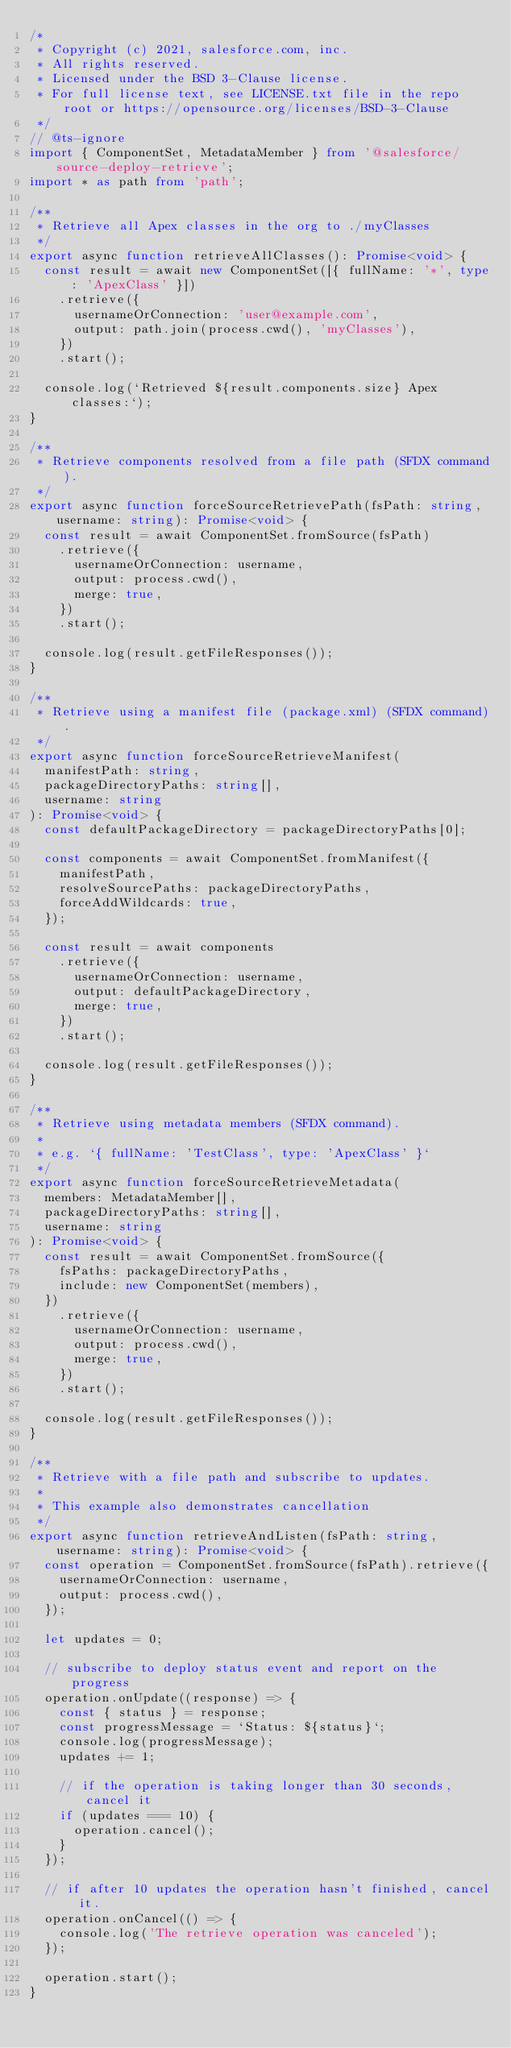<code> <loc_0><loc_0><loc_500><loc_500><_TypeScript_>/*
 * Copyright (c) 2021, salesforce.com, inc.
 * All rights reserved.
 * Licensed under the BSD 3-Clause license.
 * For full license text, see LICENSE.txt file in the repo root or https://opensource.org/licenses/BSD-3-Clause
 */
// @ts-ignore
import { ComponentSet, MetadataMember } from '@salesforce/source-deploy-retrieve';
import * as path from 'path';

/**
 * Retrieve all Apex classes in the org to ./myClasses
 */
export async function retrieveAllClasses(): Promise<void> {
  const result = await new ComponentSet([{ fullName: '*', type: 'ApexClass' }])
    .retrieve({
      usernameOrConnection: 'user@example.com',
      output: path.join(process.cwd(), 'myClasses'),
    })
    .start();

  console.log(`Retrieved ${result.components.size} Apex classes:`);
}

/**
 * Retrieve components resolved from a file path (SFDX command).
 */
export async function forceSourceRetrievePath(fsPath: string, username: string): Promise<void> {
  const result = await ComponentSet.fromSource(fsPath)
    .retrieve({
      usernameOrConnection: username,
      output: process.cwd(),
      merge: true,
    })
    .start();

  console.log(result.getFileResponses());
}

/**
 * Retrieve using a manifest file (package.xml) (SFDX command).
 */
export async function forceSourceRetrieveManifest(
  manifestPath: string,
  packageDirectoryPaths: string[],
  username: string
): Promise<void> {
  const defaultPackageDirectory = packageDirectoryPaths[0];

  const components = await ComponentSet.fromManifest({
    manifestPath,
    resolveSourcePaths: packageDirectoryPaths,
    forceAddWildcards: true,
  });

  const result = await components
    .retrieve({
      usernameOrConnection: username,
      output: defaultPackageDirectory,
      merge: true,
    })
    .start();

  console.log(result.getFileResponses());
}

/**
 * Retrieve using metadata members (SFDX command).
 *
 * e.g. `{ fullName: 'TestClass', type: 'ApexClass' }`
 */
export async function forceSourceRetrieveMetadata(
  members: MetadataMember[],
  packageDirectoryPaths: string[],
  username: string
): Promise<void> {
  const result = await ComponentSet.fromSource({
    fsPaths: packageDirectoryPaths,
    include: new ComponentSet(members),
  })
    .retrieve({
      usernameOrConnection: username,
      output: process.cwd(),
      merge: true,
    })
    .start();

  console.log(result.getFileResponses());
}

/**
 * Retrieve with a file path and subscribe to updates.
 *
 * This example also demonstrates cancellation
 */
export async function retrieveAndListen(fsPath: string, username: string): Promise<void> {
  const operation = ComponentSet.fromSource(fsPath).retrieve({
    usernameOrConnection: username,
    output: process.cwd(),
  });

  let updates = 0;

  // subscribe to deploy status event and report on the progress
  operation.onUpdate((response) => {
    const { status } = response;
    const progressMessage = `Status: ${status}`;
    console.log(progressMessage);
    updates += 1;

    // if the operation is taking longer than 30 seconds, cancel it
    if (updates === 10) {
      operation.cancel();
    }
  });

  // if after 10 updates the operation hasn't finished, cancel it.
  operation.onCancel(() => {
    console.log('The retrieve operation was canceled');
  });

  operation.start();
}
</code> 